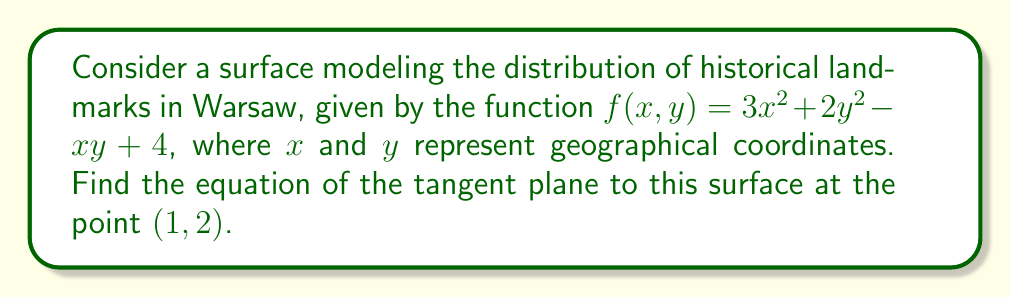Could you help me with this problem? To find the equation of the tangent plane, we need to follow these steps:

1) The general equation of a tangent plane to a surface $z = f(x,y)$ at a point $(x_0, y_0, z_0)$ is:

   $$ z - z_0 = f_x(x_0,y_0)(x-x_0) + f_y(x_0,y_0)(y-y_0) $$

   where $f_x$ and $f_y$ are partial derivatives of $f$ with respect to $x$ and $y$.

2) Calculate the partial derivatives:
   $$ f_x = 6x - y $$
   $$ f_y = 4y - x $$

3) Evaluate these at the point $(1, 2)$:
   $$ f_x(1,2) = 6(1) - 2 = 4 $$
   $$ f_y(1,2) = 4(2) - 1 = 7 $$

4) Calculate $z_0 = f(1,2)$:
   $$ z_0 = 3(1)^2 + 2(2)^2 - 1(2) + 4 = 3 + 8 - 2 + 4 = 13 $$

5) Substitute these values into the general equation:

   $$ z - 13 = 4(x-1) + 7(y-2) $$

6) Simplify:

   $$ z = 4x + 7y + 2 $$

This is the equation of the tangent plane.
Answer: $z = 4x + 7y + 2$ 